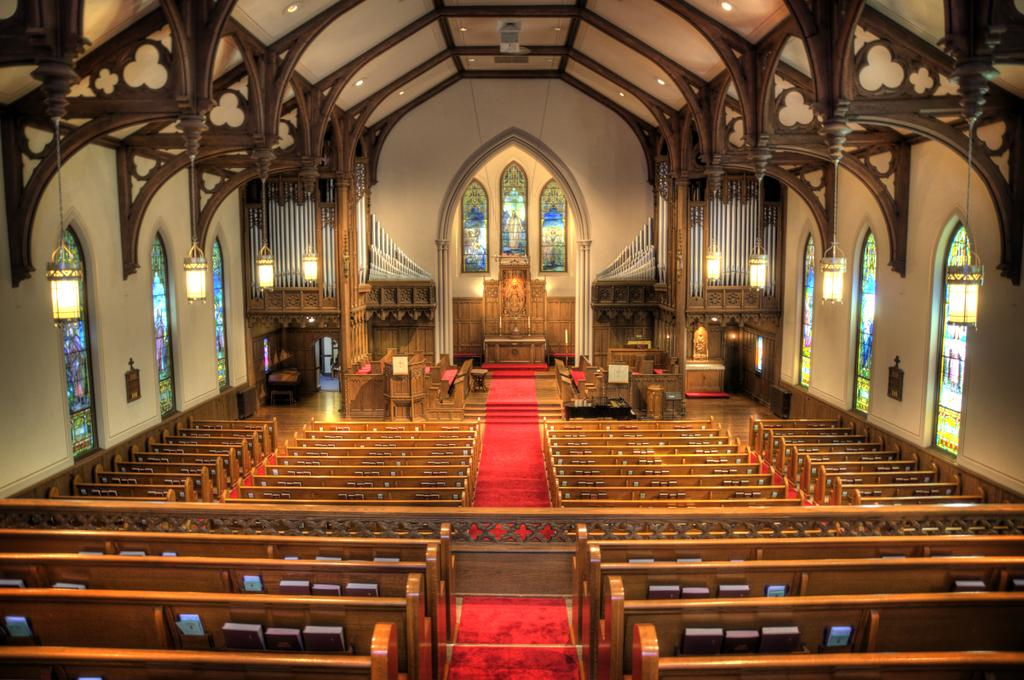Where was the image taken? The image was taken inside a church. What can be seen in the front of the image? There are branches in the front of the image. What is depicted on the wall in the back of the image? There is an image of Christ on the wall in the back of the image. What is hanging from the ceiling in the image? There are lamps hanging from the ceiling on either side of the image. What industry is being represented by the branches in the image? The branches in the image do not represent any industry; they are simply a part of the scene. 